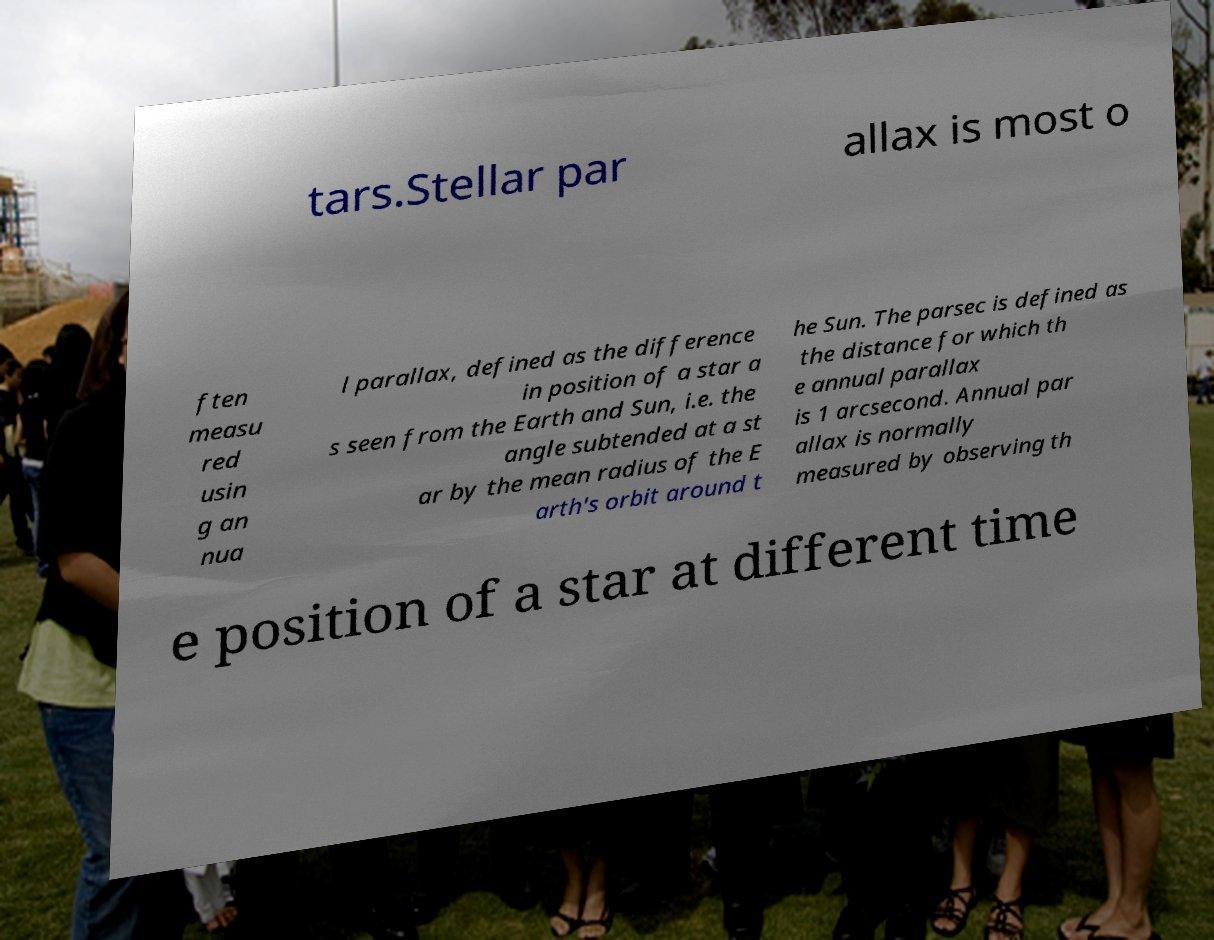Could you assist in decoding the text presented in this image and type it out clearly? tars.Stellar par allax is most o ften measu red usin g an nua l parallax, defined as the difference in position of a star a s seen from the Earth and Sun, i.e. the angle subtended at a st ar by the mean radius of the E arth's orbit around t he Sun. The parsec is defined as the distance for which th e annual parallax is 1 arcsecond. Annual par allax is normally measured by observing th e position of a star at different time 